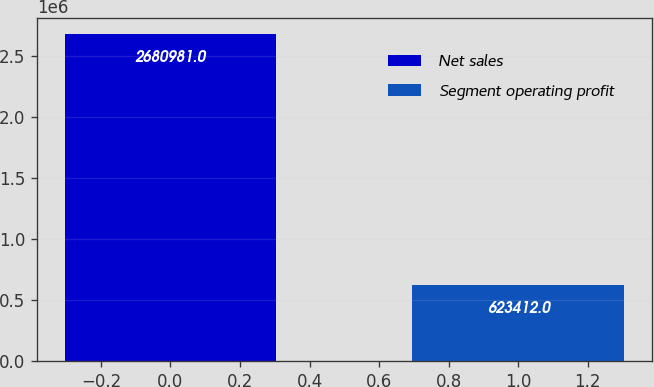Convert chart to OTSL. <chart><loc_0><loc_0><loc_500><loc_500><bar_chart><fcel>Net sales<fcel>Segment operating profit<nl><fcel>2.68098e+06<fcel>623412<nl></chart> 